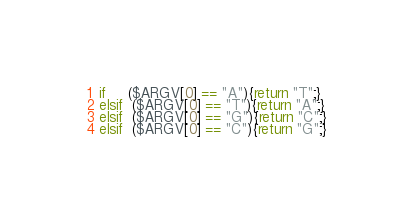Convert code to text. <code><loc_0><loc_0><loc_500><loc_500><_Perl_>if     ($ARGV[0] == "A"){return "T";}
elsif  ($ARGV[0] == "T"){return "A";} 
elsif  ($ARGV[0] == "G"){return "C";} 
elsif  ($ARGV[0] == "C"){return "G";} </code> 